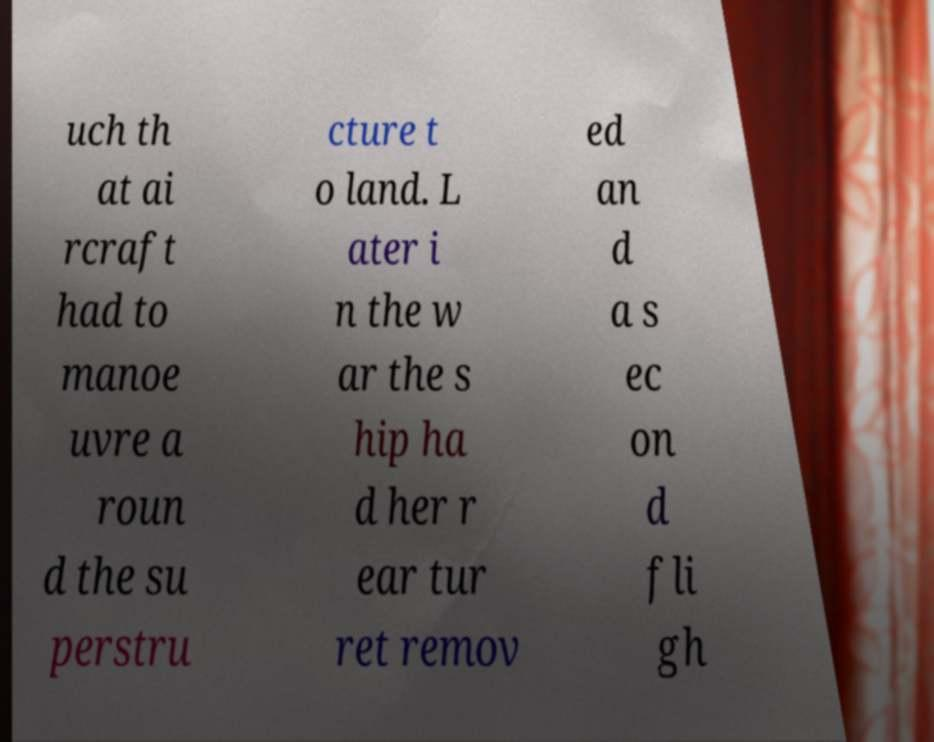Please read and relay the text visible in this image. What does it say? uch th at ai rcraft had to manoe uvre a roun d the su perstru cture t o land. L ater i n the w ar the s hip ha d her r ear tur ret remov ed an d a s ec on d fli gh 